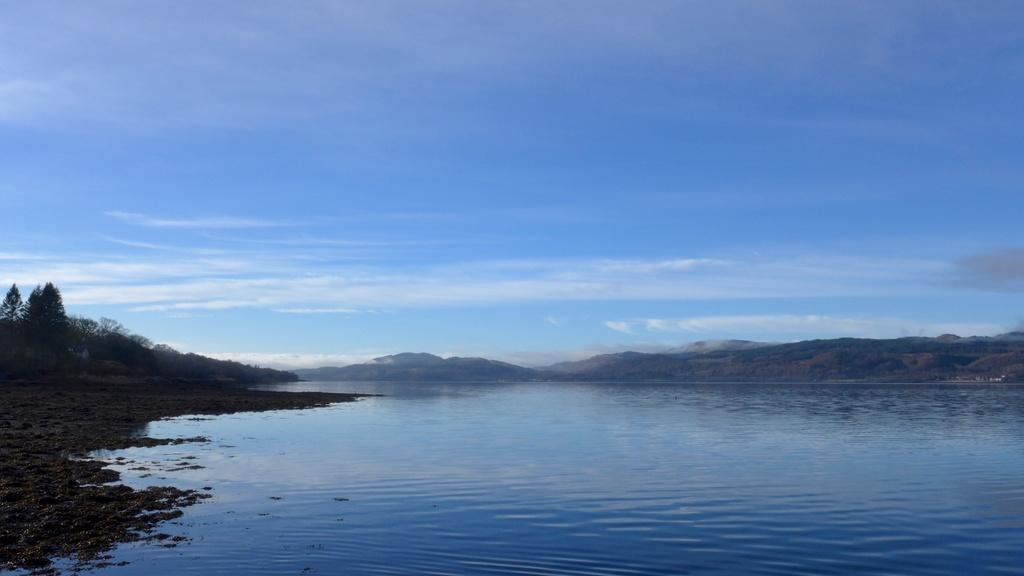What is visible in the image? Water is visible in the image. What can be seen in the background of the image? There are trees, hills, and the sky visible in the background of the image. How many pies are being rewarded to the person in the image? There is no person or pies present in the image. 